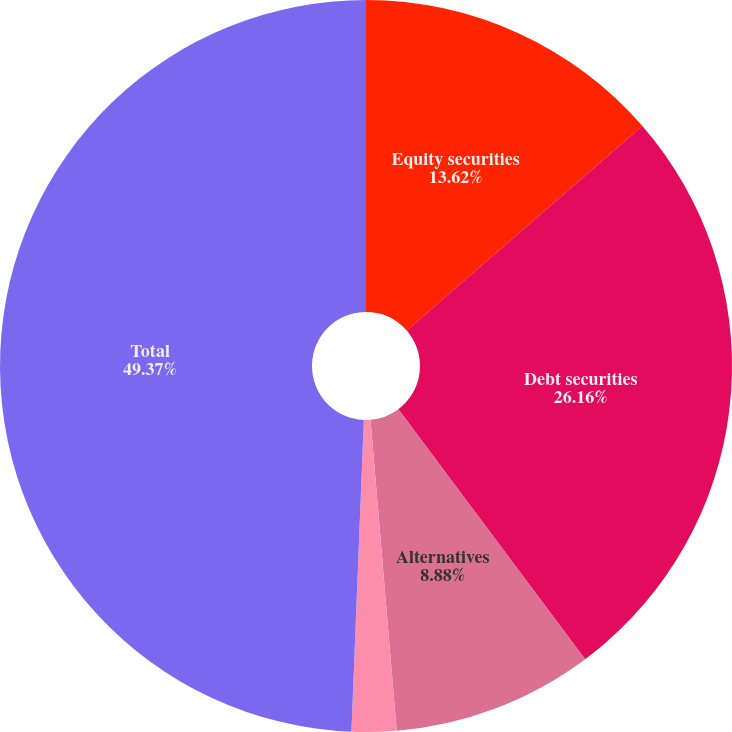Convert chart. <chart><loc_0><loc_0><loc_500><loc_500><pie_chart><fcel>Equity securities<fcel>Debt securities<fcel>Alternatives<fcel>Cash and other<fcel>Total<nl><fcel>13.62%<fcel>26.16%<fcel>8.88%<fcel>1.97%<fcel>49.36%<nl></chart> 